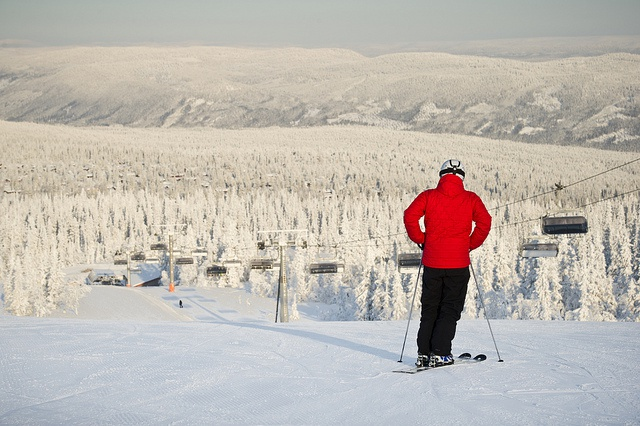Describe the objects in this image and their specific colors. I can see people in darkgray, black, red, brown, and lightgray tones, skis in darkgray, black, lightgray, and gray tones, and people in darkgray, gray, and black tones in this image. 